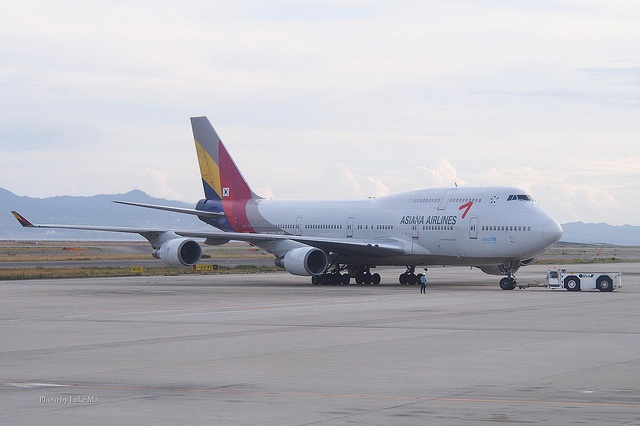Describe the objects in this image and their specific colors. I can see airplane in white, darkgray, gray, and lightgray tones, truck in white, darkgray, gray, and black tones, and people in white, black, gray, and darkgray tones in this image. 